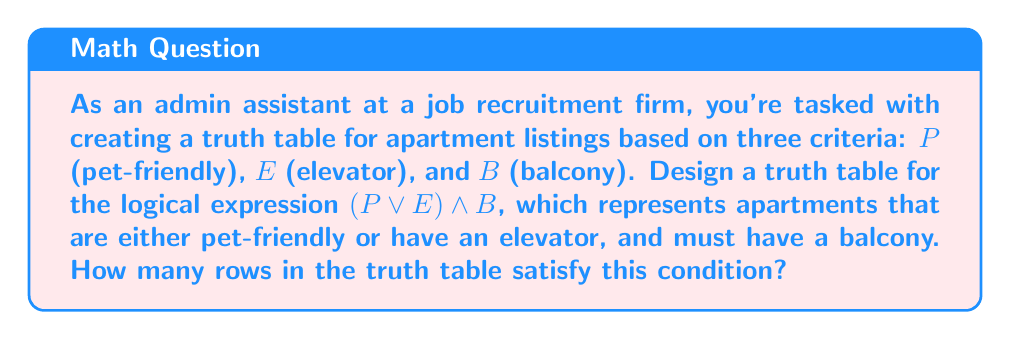Teach me how to tackle this problem. Let's approach this step-by-step:

1) First, we need to create a truth table with all possible combinations of $P$, $E$, and $B$. There will be $2^3 = 8$ rows in total.

2) Let's construct the truth table:

   $$\begin{array}{|c|c|c|c|c|c|}
   \hline
   P & E & B & P \lor E & (P \lor E) \land B \\
   \hline
   0 & 0 & 0 & 0 & 0 \\
   0 & 0 & 1 & 0 & 0 \\
   0 & 1 & 0 & 1 & 0 \\
   0 & 1 & 1 & 1 & 1 \\
   1 & 0 & 0 & 1 & 0 \\
   1 & 0 & 1 & 1 & 1 \\
   1 & 1 & 0 & 1 & 0 \\
   1 & 1 & 1 & 1 & 1 \\
   \hline
   \end{array}$$

3) In the $P \lor E$ column, we put 1 if either $P$ or $E$ (or both) is 1.

4) In the $(P \lor E) \land B$ column, we put 1 only if both $(P \lor E)$ and $B$ are 1.

5) Now, we count the number of 1's in the final column $(P \lor E) \land B$.

6) There are three rows that satisfy the condition: rows 4, 6, and 8.

Therefore, there are 3 rows in the truth table that satisfy the given condition.
Answer: 3 